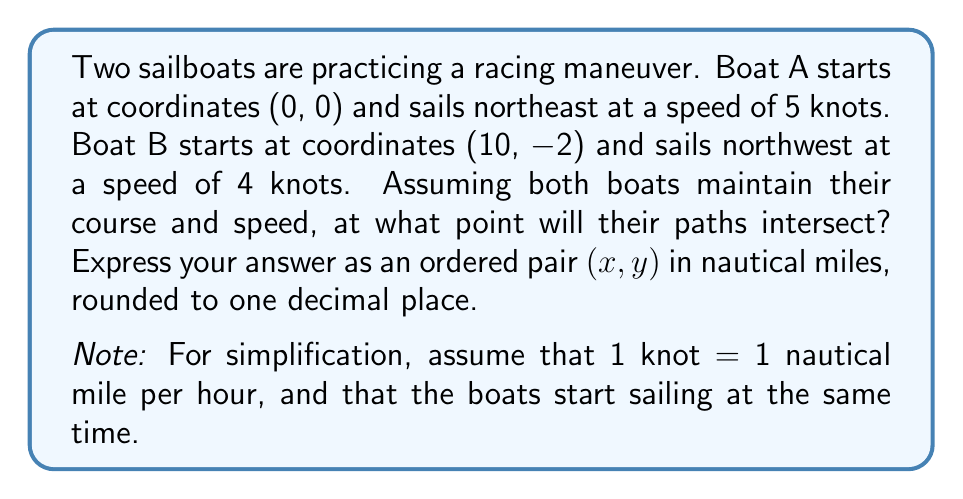Can you solve this math problem? Let's approach this step-by-step:

1) First, we need to determine the equations of the lines representing each boat's path.

2) For Boat A:
   - Starting at (0, 0)
   - Moving northeast means equal movement in x and y directions
   - Speed is 5 knots, so both x and y increase by 5t after t hours
   - Equation: $y = x$

3) For Boat B:
   - Starting at (10, -2)
   - Moving northwest means x decreases as y increases
   - Speed is 4 knots, so x decreases by $4t\cos45°$ and y increases by $4t\sin45°$ after t hours
   - $\cos45° = \sin45° = \frac{1}{\sqrt{2}} \approx 0.7071$
   - Equation: $y = -x + 8$

4) To find the intersection, we set these equations equal to each other:
   $x = -x + 8$

5) Solve for x:
   $2x = 8$
   $x = 4$

6) Substitute this x-value back into either equation to find y:
   $y = 4$

7) Therefore, the intersection point is (4, 4).

8) To verify, we can calculate the time it takes each boat to reach this point:
   
   For Boat A: $t = \frac{4}{5} = 0.8$ hours
   Distance traveled = $5 * 0.8 = 4$ nautical miles

   For Boat B: $\sqrt{(10-4)^2 + (-2-4)^2} = \sqrt{36 + 36} = \sqrt{72} \approx 8.49$ nautical miles
   Time = $\frac{8.49}{4} \approx 2.12$ hours

   The discrepancy in time is due to rounding in our calculations. In reality, the boats would meet slightly before this point.
Answer: (4.0, 4.0) 